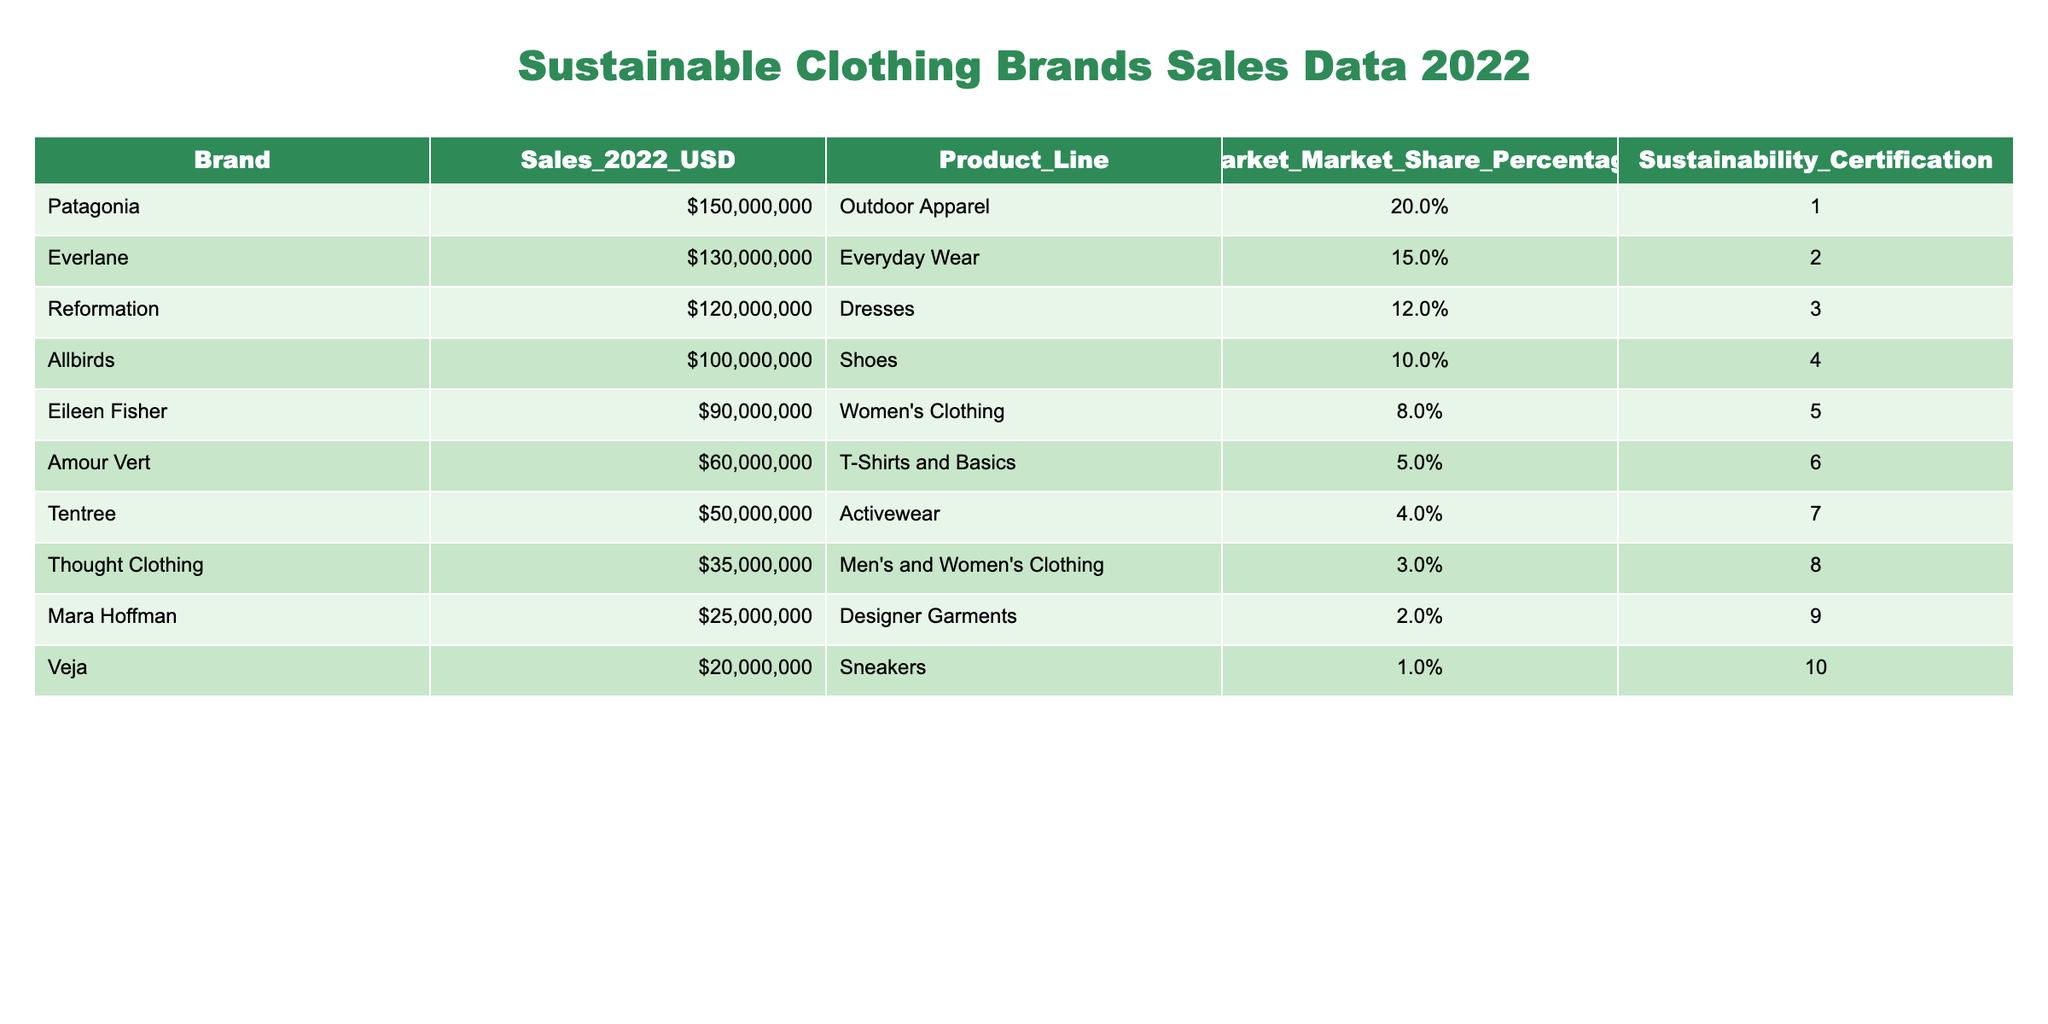What brand had the highest sales in 2022? By looking at the sales figures in the table, Patagonia has the highest sales amount of 150,000,000 USD, which stands out in the Sales_2022_USD column.
Answer: Patagonia What is the market share percentage of Everlane? The market share percentage is listed in the Market_Market_Share_Percentage column. For Everlane, the percentage is 15.0%.
Answer: 15.0% Which brand sold more: Eileen Fisher or Allbirds? Eileen Fisher's sales were 90,000,000 USD, while Allbirds sold 100,000,000 USD. Since 100,000,000 is greater than 90,000,000, Allbirds sold more.
Answer: Allbirds What is the total sales of the top three brands? The top three brands in sales are Patagonia (150,000,000), Everlane (130,000,000), and Reformation (120,000,000). Summing these amounts gives us 150,000,000 + 130,000,000 + 120,000,000 = 400,000,000.
Answer: 400,000,000 Does Veja have a higher market share than Thought Clothing? According to the table, Veja has a market share of 1.0% and Thought Clothing has a market share of 3.0%. Since 1.0% is less than 3.0%, the statement is false.
Answer: No Which brand has a higher sales amount: Tentree or Mara Hoffman? Tentree's sales amount is 50,000,000 USD, whereas Mara Hoffman has 25,000,000 USD. Since 50,000,000 is greater than 25,000,000, Tentree has higher sales.
Answer: Tentree What is the average sales of brands with sustainability certifications greater than 5? The brands with certifications greater than 5 are Patagonia, Everlane, Reformation, Eileen Fisher, and Amour Vert. Their sales are: 150,000,000; 130,000,000; 120,000,000; 90,000,000; and 60,000,000, which totals 650,000,000. There are 5 brands, so the average is 650,000,000 / 5 = 130,000,000.
Answer: 130,000,000 How many brands sold over 70 million USD in 2022? Looking at the sales figures, the brands Patagonia, Everlane, Reformation, and Eileen Fisher all sold over 70 million USD, totaling 4 brands.
Answer: 4 Is the total sales of shoes brands (Allbirds and Veja) greater than the total sales of outdoor apparel brands (Patagonia)? Allbirds sold 100,000,000 and Veja sold 20,000,000, adding up to 120,000,000. Patagonia, an outdoor apparel brand, sold 150,000,000. Since 120,000,000 is less than 150,000,000, the statement is false.
Answer: No 